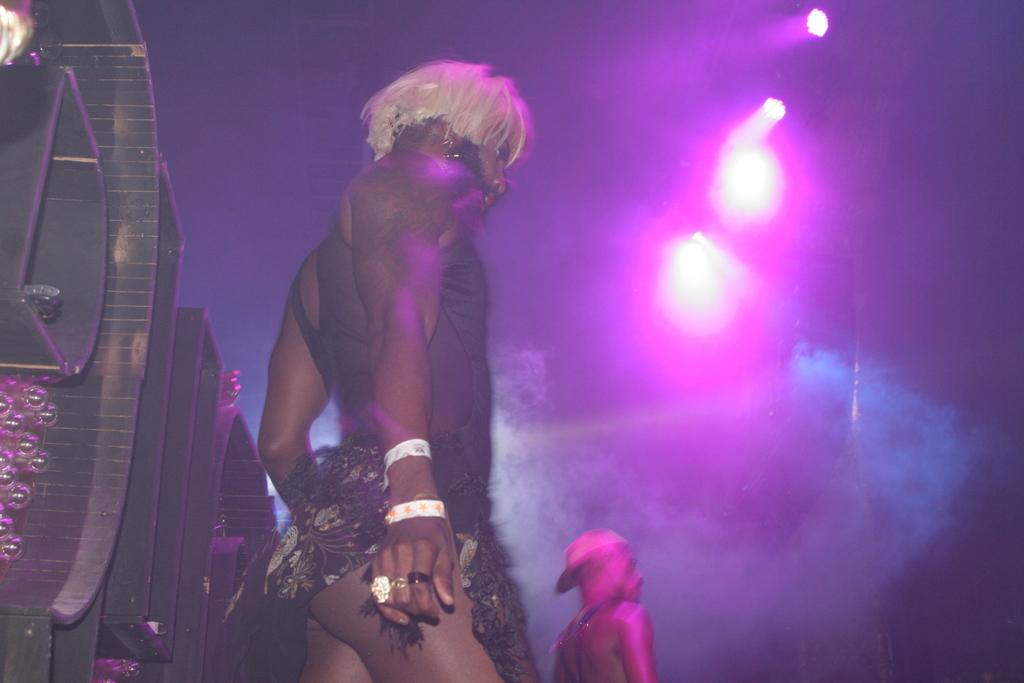How many people are in the image? There are two persons in the image. What are the persons wearing? The persons are wearing different costumes. What can be seen behind the persons? There is a metal structure behind the persons. What is the lighting like in the background of the image? There are colorful lights in the background of the image. How many ladybugs can be seen crawling on the metal structure in the image? There are no ladybugs present in the image; the metal structure is the only notable feature behind the persons. Are there any beds visible in the image? There are no beds present in the image; the focus is on the two persons and the metal structure behind them. 